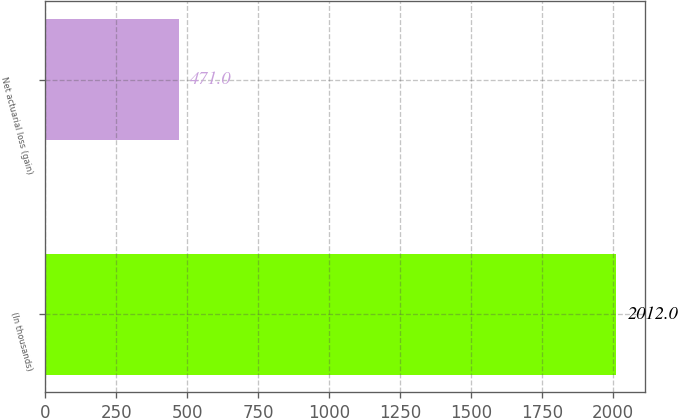Convert chart to OTSL. <chart><loc_0><loc_0><loc_500><loc_500><bar_chart><fcel>(In thousands)<fcel>Net actuarial loss (gain)<nl><fcel>2012<fcel>471<nl></chart> 